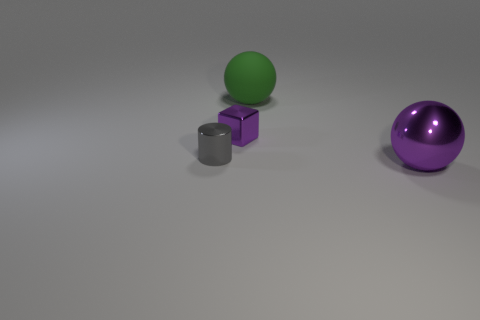Add 3 small cubes. How many objects exist? 7 Subtract all cylinders. How many objects are left? 3 Add 4 small purple matte spheres. How many small purple matte spheres exist? 4 Subtract 0 cyan cylinders. How many objects are left? 4 Subtract all big purple things. Subtract all big matte objects. How many objects are left? 2 Add 4 tiny metal cubes. How many tiny metal cubes are left? 5 